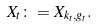Convert formula to latex. <formula><loc_0><loc_0><loc_500><loc_500>X _ { t } \colon = X _ { k _ { t } , g _ { t } } .</formula> 